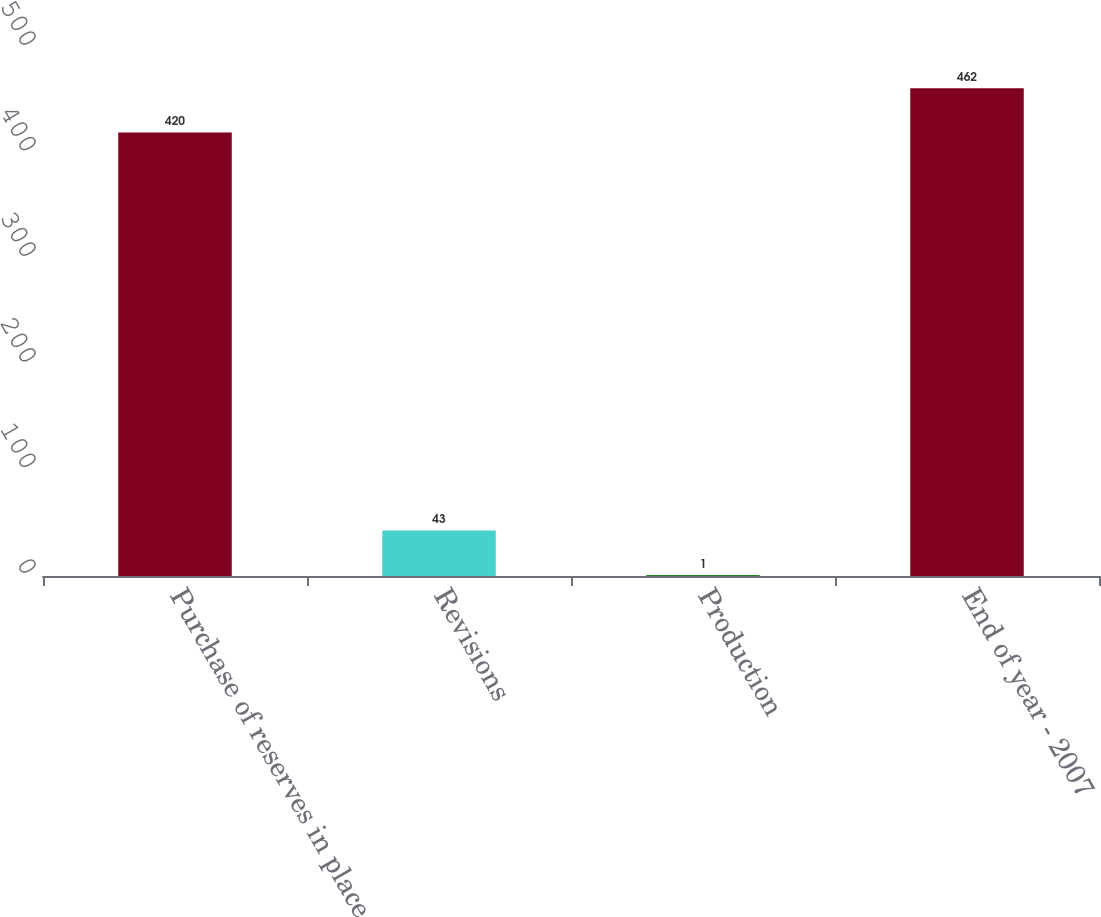Convert chart. <chart><loc_0><loc_0><loc_500><loc_500><bar_chart><fcel>Purchase of reserves in place<fcel>Revisions<fcel>Production<fcel>End of year - 2007<nl><fcel>420<fcel>43<fcel>1<fcel>462<nl></chart> 